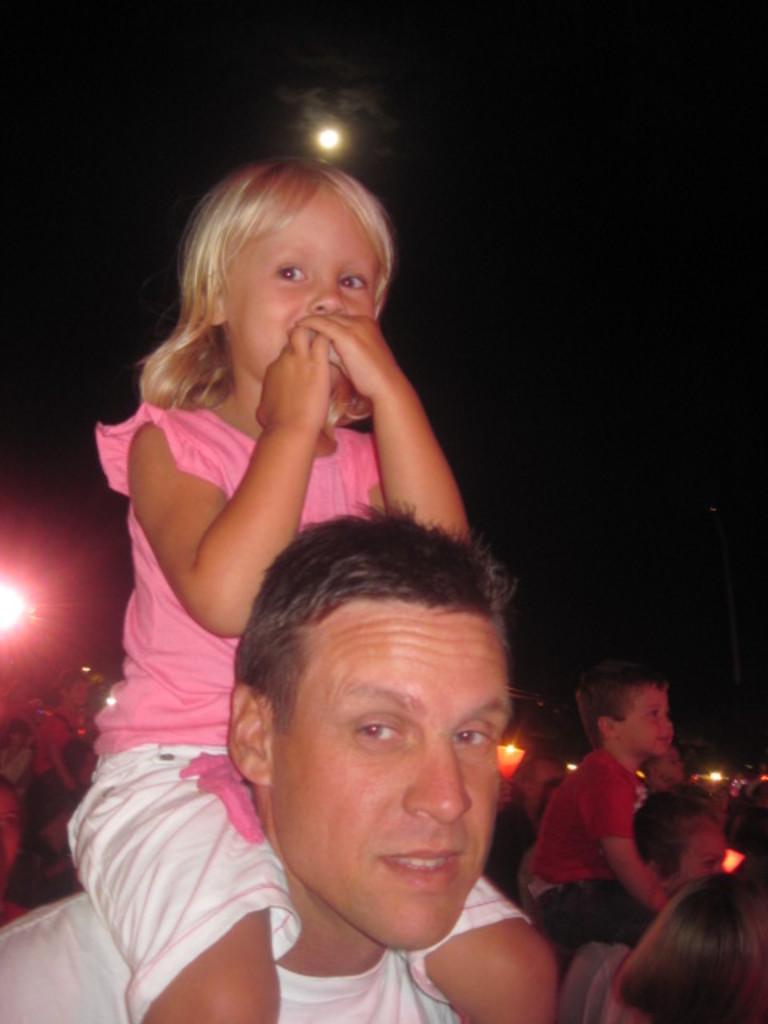Please provide a concise description of this image. In this picture we can see a group of people and some kids are sitting on the person's shoulders. Behind the people there are lights and there is a moon in the sky. 